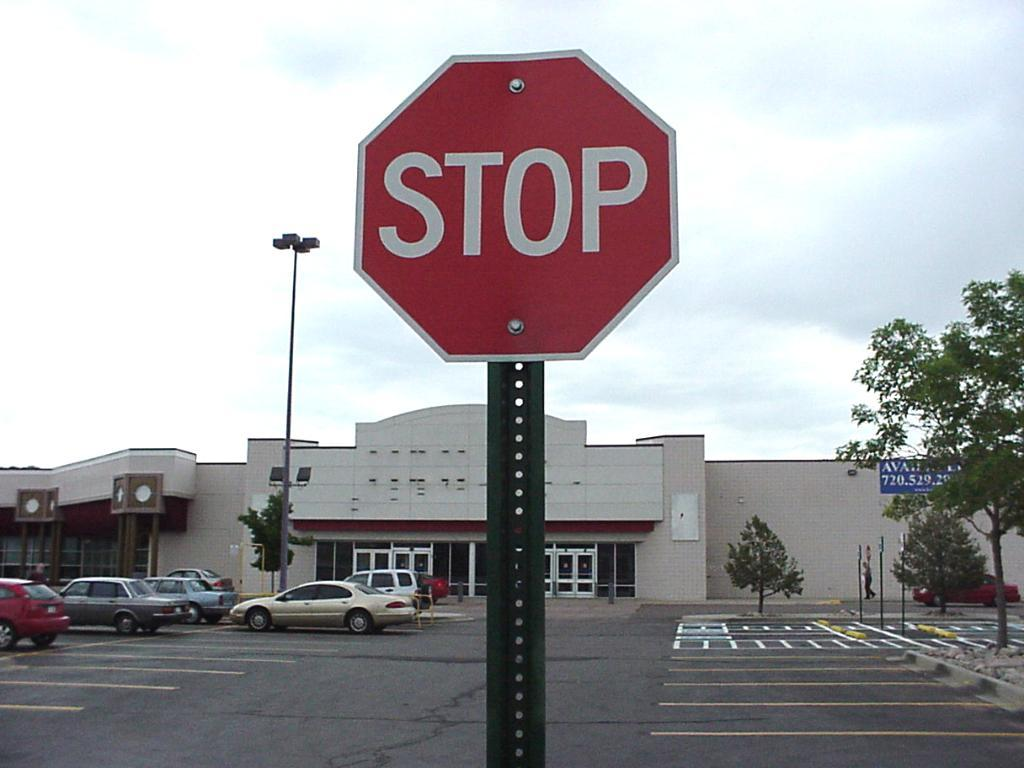<image>
Share a concise interpretation of the image provided. The red and white sign is a stop sign 